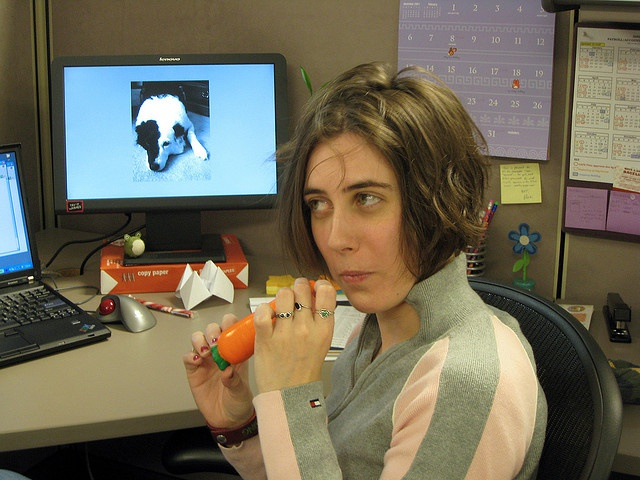Describe the objects in this image and their specific colors. I can see people in gray, tan, black, and olive tones, tv in gray, lightblue, black, and white tones, chair in gray, black, and darkgreen tones, laptop in gray, black, lightblue, and darkgreen tones, and dog in gray, white, black, lightblue, and navy tones in this image. 